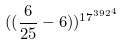Convert formula to latex. <formula><loc_0><loc_0><loc_500><loc_500>( ( \frac { 6 } { 2 5 } - 6 ) ) ^ { { 1 7 ^ { 3 9 2 } } ^ { 4 } }</formula> 